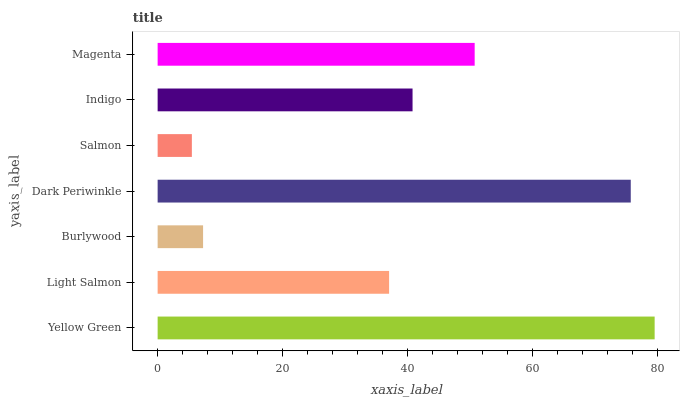Is Salmon the minimum?
Answer yes or no. Yes. Is Yellow Green the maximum?
Answer yes or no. Yes. Is Light Salmon the minimum?
Answer yes or no. No. Is Light Salmon the maximum?
Answer yes or no. No. Is Yellow Green greater than Light Salmon?
Answer yes or no. Yes. Is Light Salmon less than Yellow Green?
Answer yes or no. Yes. Is Light Salmon greater than Yellow Green?
Answer yes or no. No. Is Yellow Green less than Light Salmon?
Answer yes or no. No. Is Indigo the high median?
Answer yes or no. Yes. Is Indigo the low median?
Answer yes or no. Yes. Is Yellow Green the high median?
Answer yes or no. No. Is Dark Periwinkle the low median?
Answer yes or no. No. 